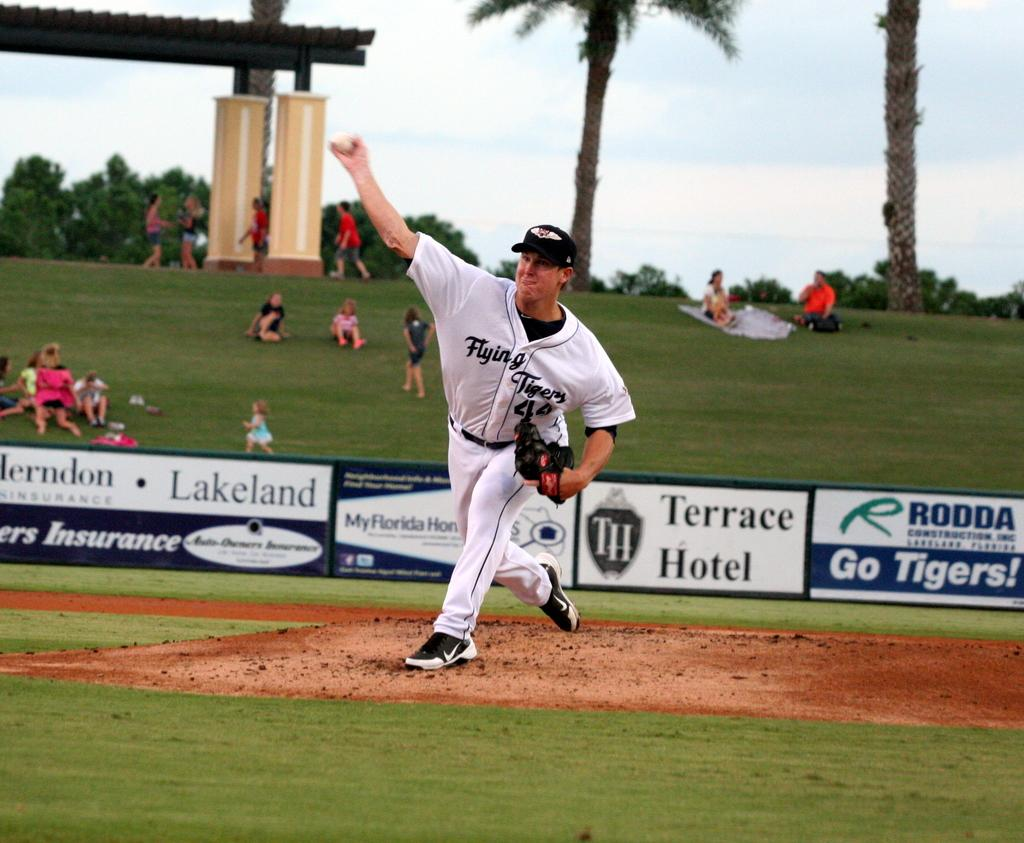<image>
Share a concise interpretation of the image provided. A pitcher is throwing a ball at a baseball game sponsored by Terrace Hotel. 